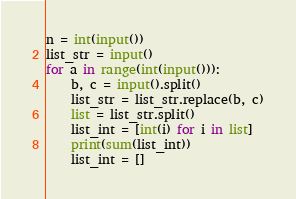Convert code to text. <code><loc_0><loc_0><loc_500><loc_500><_Python_>n = int(input())
list_str = input()
for a in range(int(input())):
    b, c = input().split()
    list_str = list_str.replace(b, c)
    list = list_str.split()
    list_int = [int(i) for i in list]
    print(sum(list_int))
    list_int = []</code> 